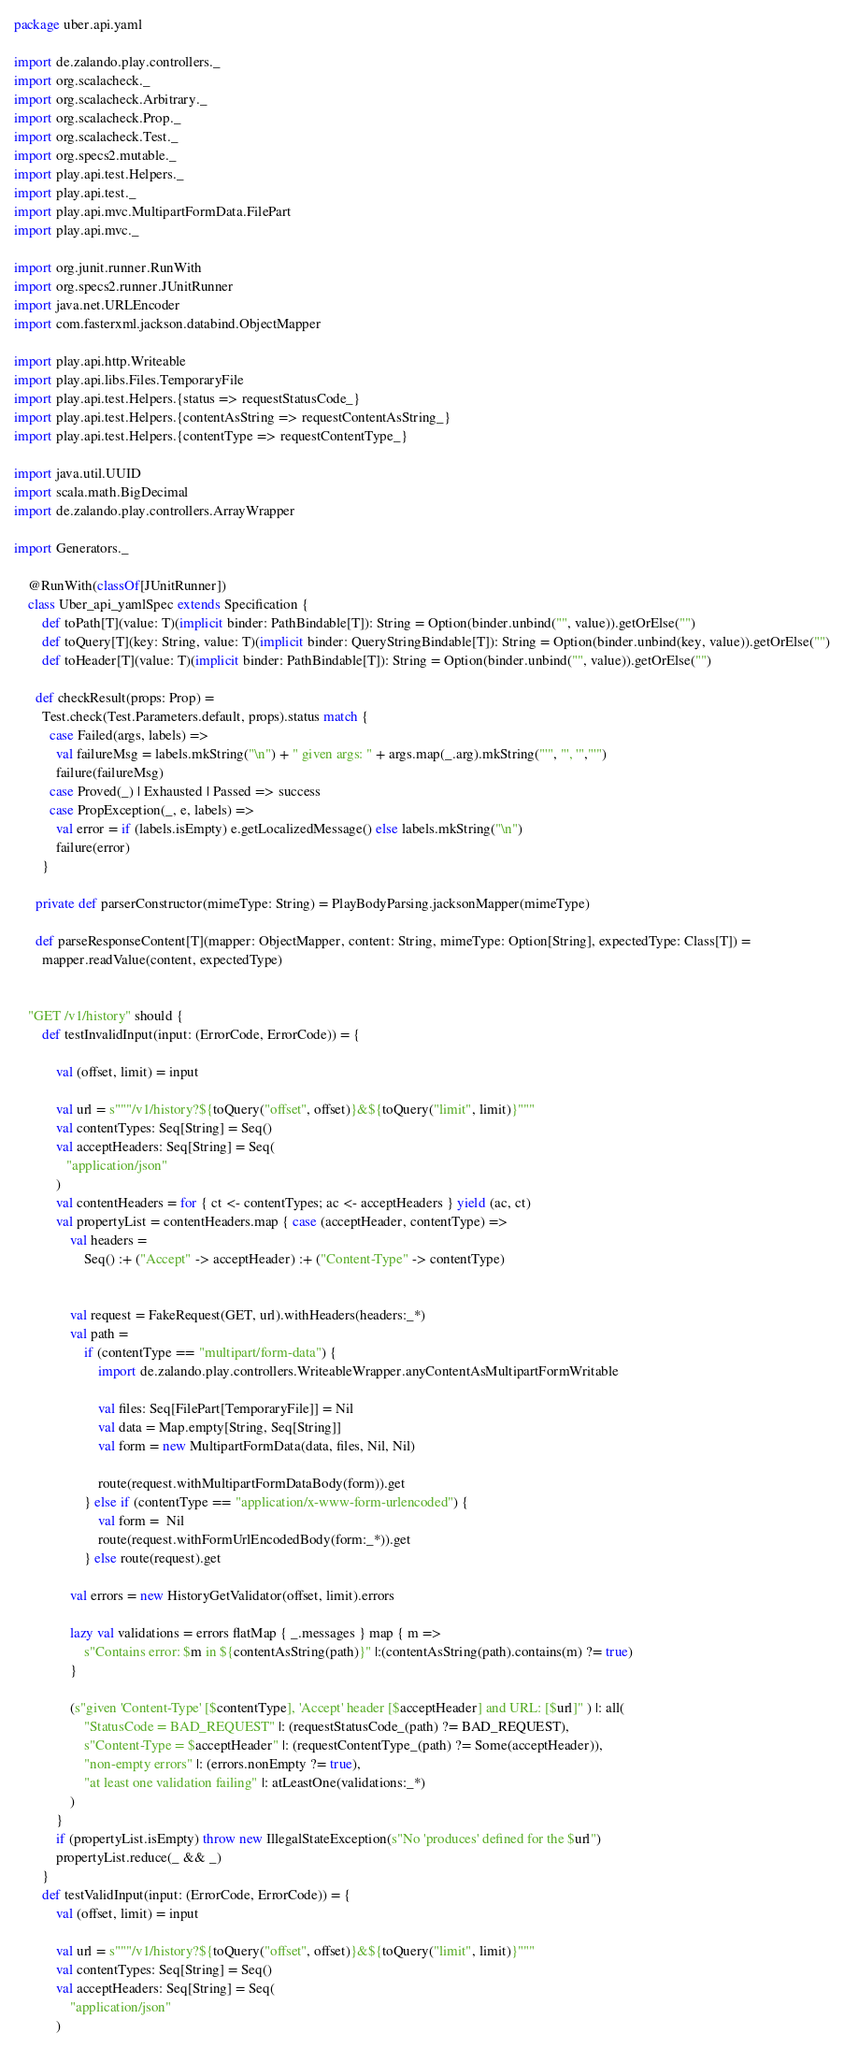<code> <loc_0><loc_0><loc_500><loc_500><_Scala_>package uber.api.yaml

import de.zalando.play.controllers._
import org.scalacheck._
import org.scalacheck.Arbitrary._
import org.scalacheck.Prop._
import org.scalacheck.Test._
import org.specs2.mutable._
import play.api.test.Helpers._
import play.api.test._
import play.api.mvc.MultipartFormData.FilePart
import play.api.mvc._

import org.junit.runner.RunWith
import org.specs2.runner.JUnitRunner
import java.net.URLEncoder
import com.fasterxml.jackson.databind.ObjectMapper

import play.api.http.Writeable
import play.api.libs.Files.TemporaryFile
import play.api.test.Helpers.{status => requestStatusCode_}
import play.api.test.Helpers.{contentAsString => requestContentAsString_}
import play.api.test.Helpers.{contentType => requestContentType_}

import java.util.UUID
import scala.math.BigDecimal
import de.zalando.play.controllers.ArrayWrapper

import Generators._

    @RunWith(classOf[JUnitRunner])
    class Uber_api_yamlSpec extends Specification {
        def toPath[T](value: T)(implicit binder: PathBindable[T]): String = Option(binder.unbind("", value)).getOrElse("")
        def toQuery[T](key: String, value: T)(implicit binder: QueryStringBindable[T]): String = Option(binder.unbind(key, value)).getOrElse("")
        def toHeader[T](value: T)(implicit binder: PathBindable[T]): String = Option(binder.unbind("", value)).getOrElse("")

      def checkResult(props: Prop) =
        Test.check(Test.Parameters.default, props).status match {
          case Failed(args, labels) =>
            val failureMsg = labels.mkString("\n") + " given args: " + args.map(_.arg).mkString("'", "', '","'")
            failure(failureMsg)
          case Proved(_) | Exhausted | Passed => success
          case PropException(_, e, labels) =>
            val error = if (labels.isEmpty) e.getLocalizedMessage() else labels.mkString("\n")
            failure(error)
        }

      private def parserConstructor(mimeType: String) = PlayBodyParsing.jacksonMapper(mimeType)

      def parseResponseContent[T](mapper: ObjectMapper, content: String, mimeType: Option[String], expectedType: Class[T]) =
        mapper.readValue(content, expectedType)


    "GET /v1/history" should {
        def testInvalidInput(input: (ErrorCode, ErrorCode)) = {

            val (offset, limit) = input

            val url = s"""/v1/history?${toQuery("offset", offset)}&${toQuery("limit", limit)}"""
            val contentTypes: Seq[String] = Seq()
            val acceptHeaders: Seq[String] = Seq(
               "application/json"
            )
            val contentHeaders = for { ct <- contentTypes; ac <- acceptHeaders } yield (ac, ct)
            val propertyList = contentHeaders.map { case (acceptHeader, contentType) =>
                val headers =
                    Seq() :+ ("Accept" -> acceptHeader) :+ ("Content-Type" -> contentType)


                val request = FakeRequest(GET, url).withHeaders(headers:_*)
                val path =
                    if (contentType == "multipart/form-data") {
                        import de.zalando.play.controllers.WriteableWrapper.anyContentAsMultipartFormWritable

                        val files: Seq[FilePart[TemporaryFile]] = Nil
                        val data = Map.empty[String, Seq[String]] 
                        val form = new MultipartFormData(data, files, Nil, Nil)

                        route(request.withMultipartFormDataBody(form)).get
                    } else if (contentType == "application/x-www-form-urlencoded") {
                        val form =  Nil
                        route(request.withFormUrlEncodedBody(form:_*)).get
                    } else route(request).get

                val errors = new HistoryGetValidator(offset, limit).errors

                lazy val validations = errors flatMap { _.messages } map { m =>
                    s"Contains error: $m in ${contentAsString(path)}" |:(contentAsString(path).contains(m) ?= true)
                }

                (s"given 'Content-Type' [$contentType], 'Accept' header [$acceptHeader] and URL: [$url]" ) |: all(
                    "StatusCode = BAD_REQUEST" |: (requestStatusCode_(path) ?= BAD_REQUEST),
                    s"Content-Type = $acceptHeader" |: (requestContentType_(path) ?= Some(acceptHeader)),
                    "non-empty errors" |: (errors.nonEmpty ?= true),
                    "at least one validation failing" |: atLeastOne(validations:_*)
                )
            }
            if (propertyList.isEmpty) throw new IllegalStateException(s"No 'produces' defined for the $url")
            propertyList.reduce(_ && _)
        }
        def testValidInput(input: (ErrorCode, ErrorCode)) = {
            val (offset, limit) = input
            
            val url = s"""/v1/history?${toQuery("offset", offset)}&${toQuery("limit", limit)}"""
            val contentTypes: Seq[String] = Seq()
            val acceptHeaders: Seq[String] = Seq(
                "application/json"
            )</code> 